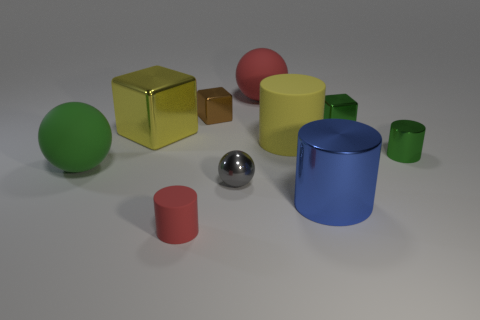What number of objects are either metallic things that are on the right side of the small gray thing or blue things?
Your answer should be very brief. 3. What number of other objects are there of the same color as the big shiny cylinder?
Keep it short and to the point. 0. Are there an equal number of red matte cylinders behind the large green ball and large gray rubber objects?
Your response must be concise. Yes. There is a big rubber thing that is on the left side of the metal block left of the small brown block; what number of green rubber objects are right of it?
Give a very brief answer. 0. Is there any other thing that has the same size as the gray thing?
Provide a succinct answer. Yes. Do the red cylinder and the green object that is left of the metal sphere have the same size?
Offer a very short reply. No. How many tiny brown matte cylinders are there?
Offer a terse response. 0. There is a green shiny object that is in front of the yellow metal cube; is it the same size as the red matte object to the left of the small brown cube?
Give a very brief answer. Yes. What color is the tiny shiny thing that is the same shape as the large red rubber thing?
Your answer should be compact. Gray. Is the yellow matte object the same shape as the large green matte object?
Your answer should be very brief. No. 